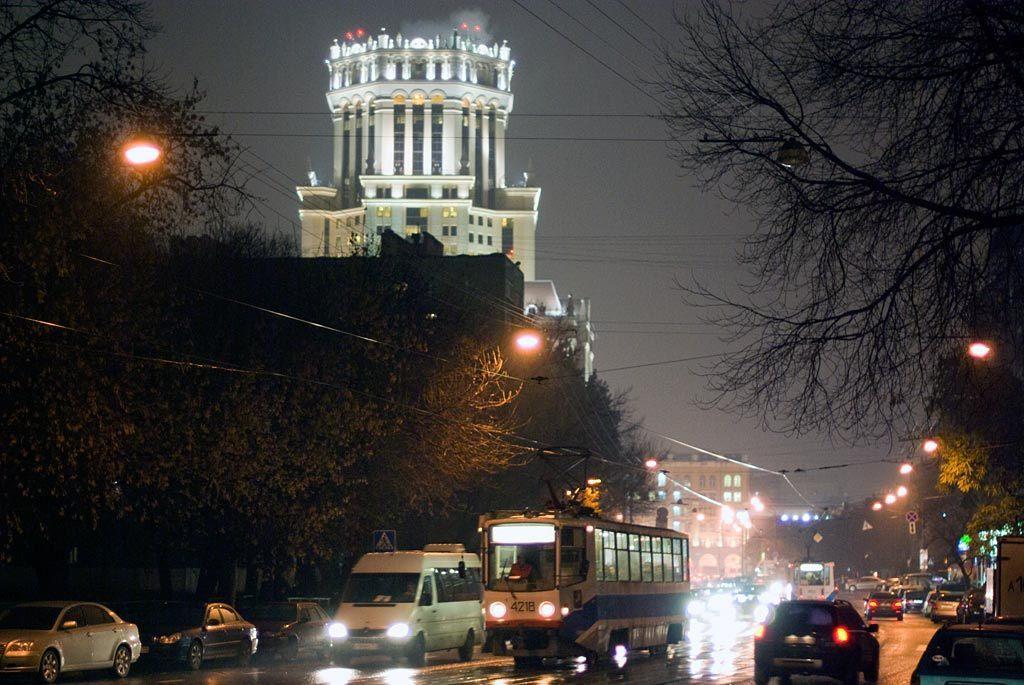Describe this image in one or two sentences. This image consists of many vehicles moving on the road. On the left and right there are trees. In the middle, there is a building. At the top, there is a sky. On the right, there are lights. 